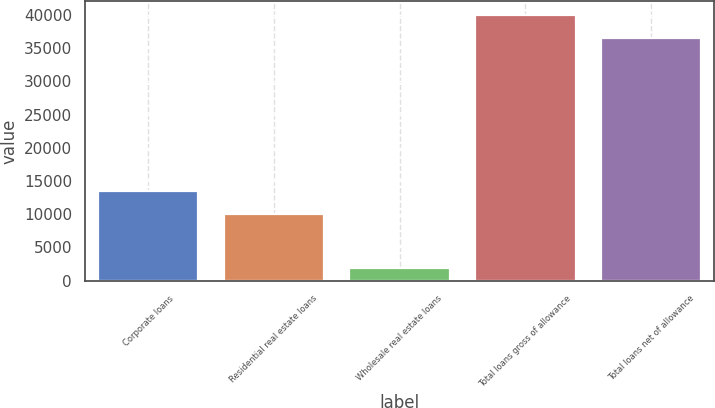Convert chart. <chart><loc_0><loc_0><loc_500><loc_500><bar_chart><fcel>Corporate loans<fcel>Residential real estate loans<fcel>Wholesale real estate loans<fcel>Total loans gross of allowance<fcel>Total loans net of allowance<nl><fcel>13490.6<fcel>10006<fcel>1855<fcel>40029.6<fcel>36545<nl></chart> 